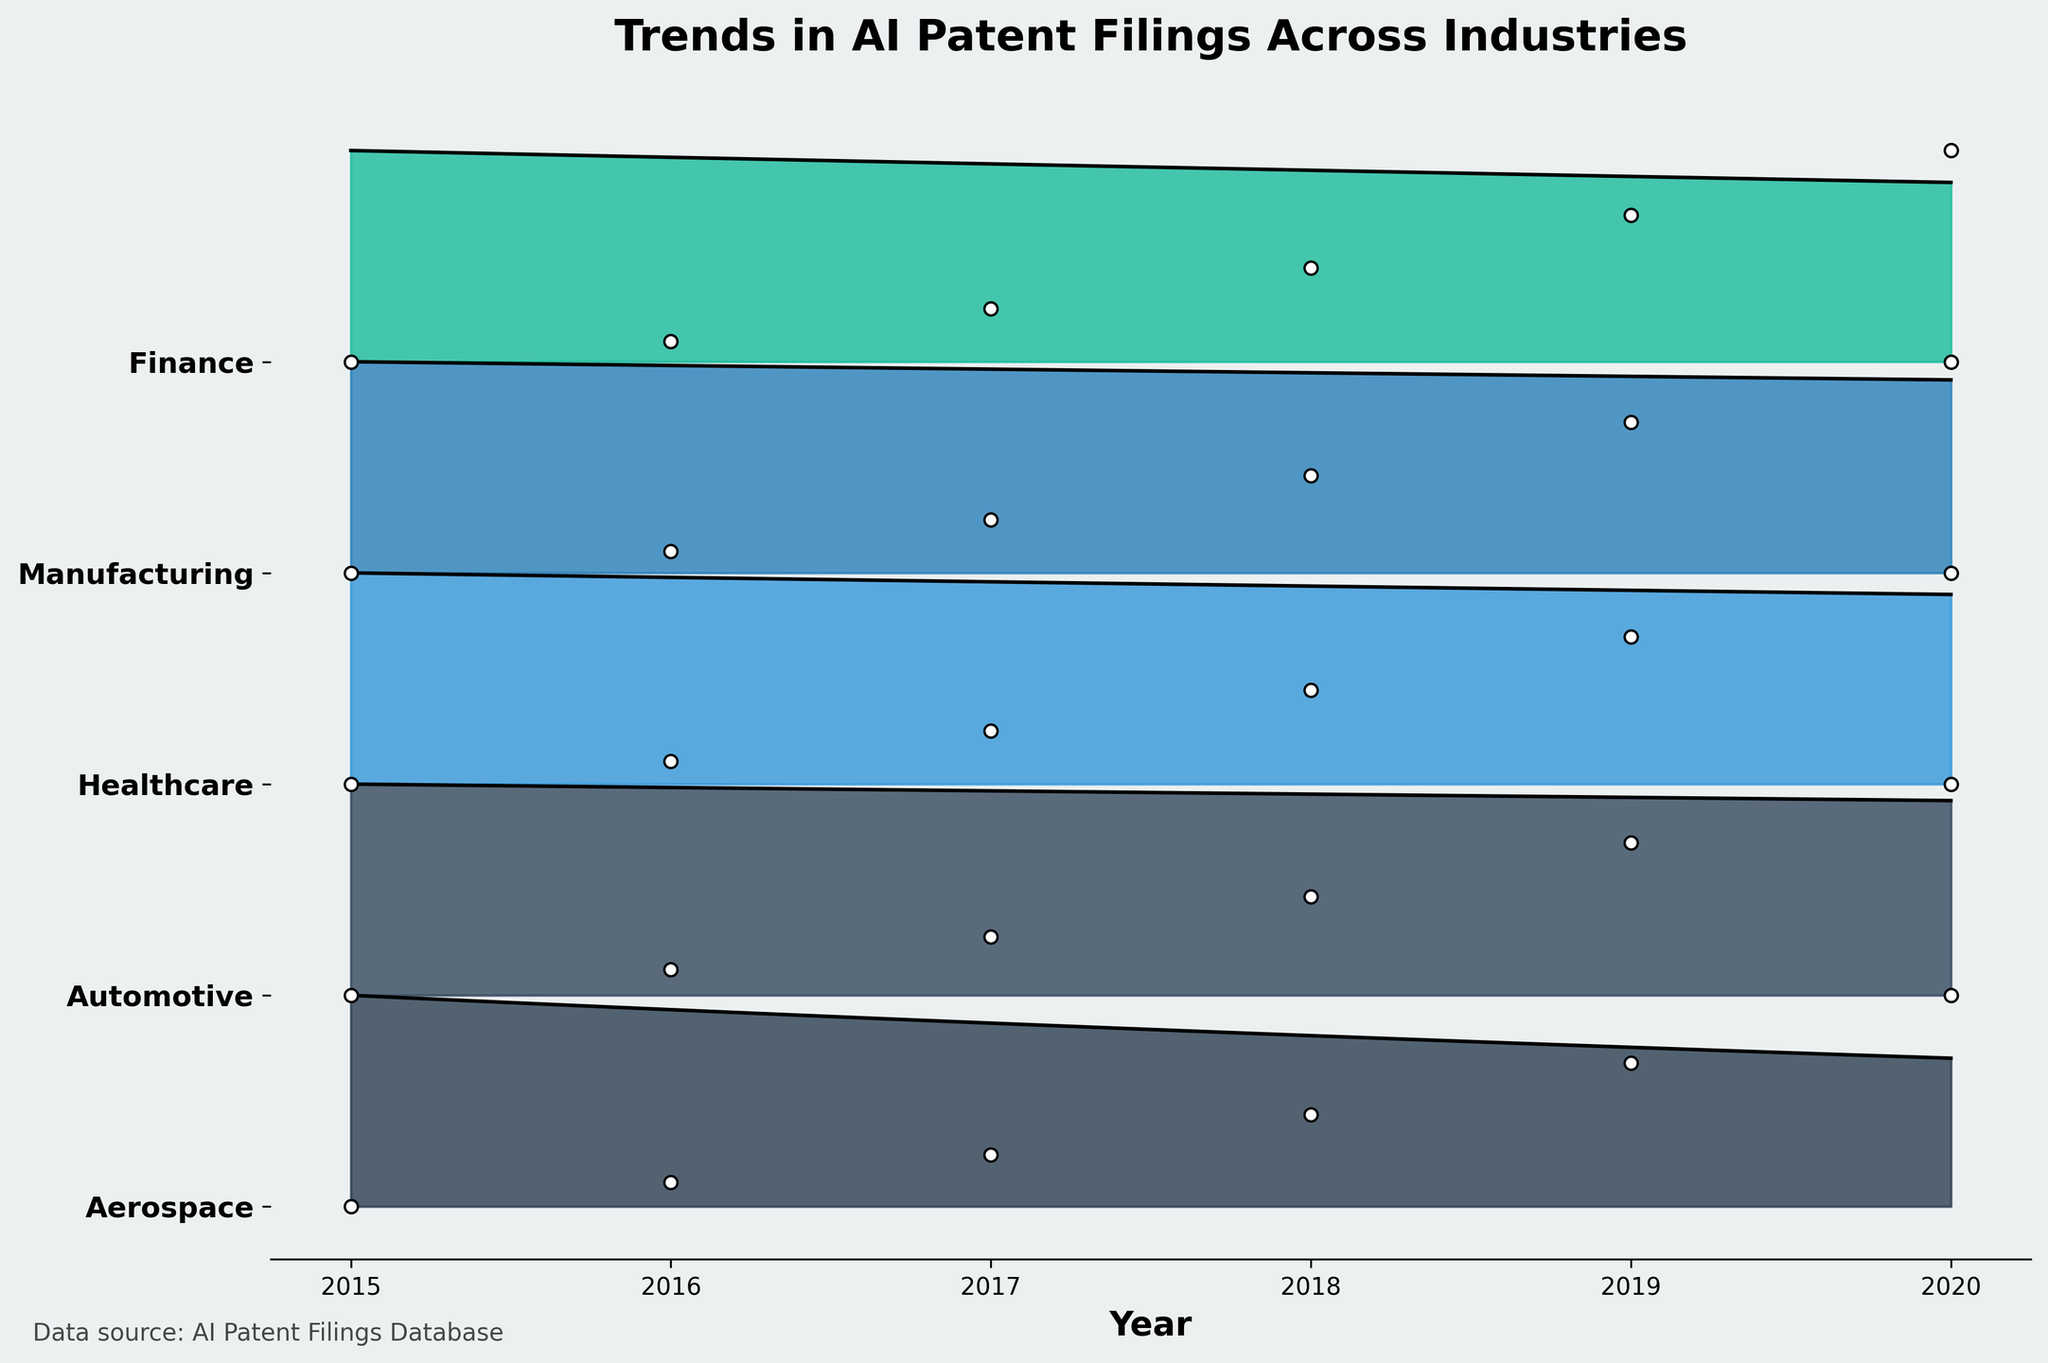What's the title of the figure? The title of a figure is usually placed at the top and describes the visual information. Here, the title is written in a bold large font and states what the figure represents.
Answer: Trends in AI Patent Filings Across Industries Which industry shows the highest number of patent filings in 2020? By observing the endpoint of each industry's line in 2020 on the x-axis, the highest ridge at that point will indicate the industry with the largest number of patents. The Automotive industry shows the longest ridge in 2020.
Answer: Automotive What's the overall trend in patent filings for artificial intelligence technologies across the industries from 2015 to 2020? The ridgelines for all industries show an increasing trend over the years. This means that the overall number of patent filings has been rising consistently across the different sectors.
Answer: Increasing Compare the patent filings in Healthcare and Aerospace industries in 2018. Which industry had more filings? Look at the heights of the ridgelines for both Healthcare and Aerospace in 2018 along the x-axis. The taller ridge indicates a higher number of patents. Healthcare shows a higher ridge compared to Aerospace in 2018.
Answer: Healthcare In which year did the Manufacturing industry see the greatest increase in patent filings? Identify the years along the x-axis where there's a noticeable jump in the ridge's height for Manufacturing. The significant increase appears between 2019 and 2020.
Answer: 2019 to 2020 How does the trend in patent filings for the Finance industry compare to that in the Automotive industry over the years? Observe the ridgelines for both Finance and Automotive. Automotive shows a more steeply increasing trend, while Finance increases but at a lesser rate.
Answer: Automotive increases faster What's the average number of patent filings per year in the Healthcare industry from 2015 to 2020? Sum the values for the Healthcare industry from 2015 to 2020: 150 + 240 + 360 + 520 + 730 + 980 = 2980. Divide by 6 years.
Answer: 496.67 Which industry had the least patent filings in 2015? Look at the starting point of ridgelines for each industry on the x-axis where it meets 2015. The shortest ridge indicates the fewest patent filings. Finance has the shortest ridge in 2015.
Answer: Finance Between 2017 and 2018, which industry had the smallest increase in patent filings? Observe the change in ridge heights between 2017 and 2018 for all industries. The smallest increase is seen in Aerospace.
Answer: Aerospace What can be inferred about the diversity of industries filing for AI patents over the studied period? The presence of ridgelines for multiple industries and the increasing trend across all of them suggest that AI technology is being explored and patented across a wide variety of sectors.
Answer: AI patents span multiple industries 